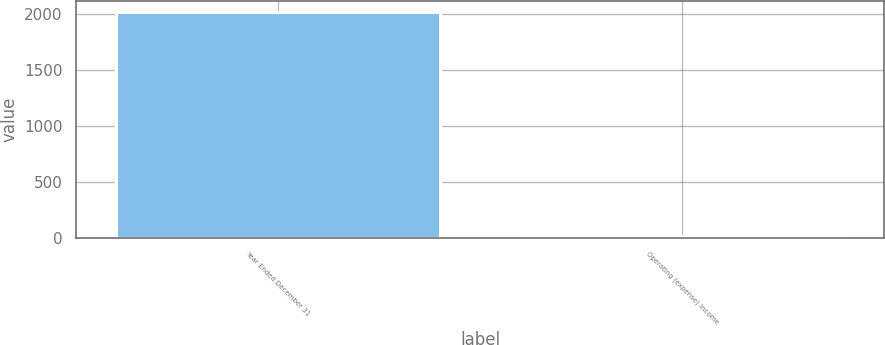<chart> <loc_0><loc_0><loc_500><loc_500><bar_chart><fcel>Year Ended December 31<fcel>Operating (expense) income<nl><fcel>2016<fcel>17<nl></chart> 